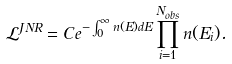Convert formula to latex. <formula><loc_0><loc_0><loc_500><loc_500>\mathcal { L } ^ { J N R } = C e ^ { - \int _ { 0 } ^ { \infty } n ( E ) d E } \prod _ { i = 1 } ^ { N _ { o b s } } n ( E _ { i } ) .</formula> 